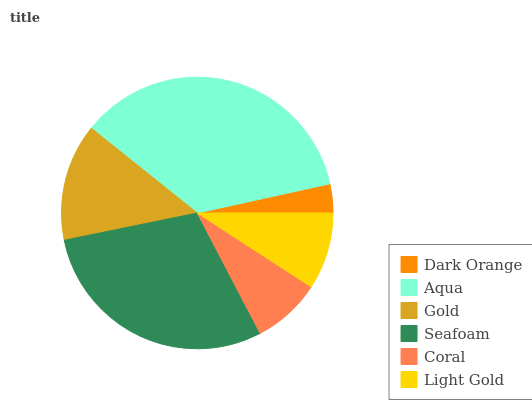Is Dark Orange the minimum?
Answer yes or no. Yes. Is Aqua the maximum?
Answer yes or no. Yes. Is Gold the minimum?
Answer yes or no. No. Is Gold the maximum?
Answer yes or no. No. Is Aqua greater than Gold?
Answer yes or no. Yes. Is Gold less than Aqua?
Answer yes or no. Yes. Is Gold greater than Aqua?
Answer yes or no. No. Is Aqua less than Gold?
Answer yes or no. No. Is Gold the high median?
Answer yes or no. Yes. Is Light Gold the low median?
Answer yes or no. Yes. Is Dark Orange the high median?
Answer yes or no. No. Is Coral the low median?
Answer yes or no. No. 